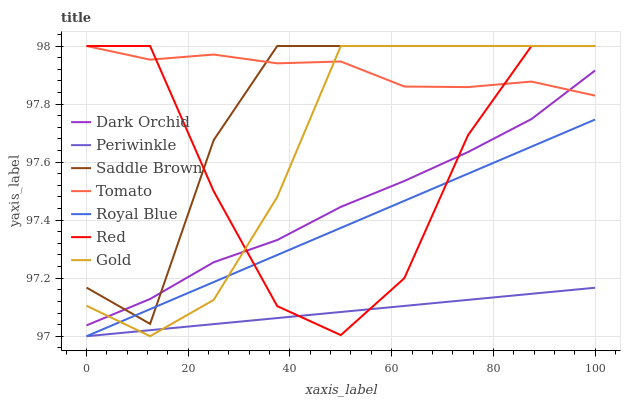Does Periwinkle have the minimum area under the curve?
Answer yes or no. Yes. Does Tomato have the maximum area under the curve?
Answer yes or no. Yes. Does Gold have the minimum area under the curve?
Answer yes or no. No. Does Gold have the maximum area under the curve?
Answer yes or no. No. Is Royal Blue the smoothest?
Answer yes or no. Yes. Is Red the roughest?
Answer yes or no. Yes. Is Gold the smoothest?
Answer yes or no. No. Is Gold the roughest?
Answer yes or no. No. Does Royal Blue have the lowest value?
Answer yes or no. Yes. Does Gold have the lowest value?
Answer yes or no. No. Does Red have the highest value?
Answer yes or no. Yes. Does Dark Orchid have the highest value?
Answer yes or no. No. Is Periwinkle less than Tomato?
Answer yes or no. Yes. Is Dark Orchid greater than Royal Blue?
Answer yes or no. Yes. Does Dark Orchid intersect Red?
Answer yes or no. Yes. Is Dark Orchid less than Red?
Answer yes or no. No. Is Dark Orchid greater than Red?
Answer yes or no. No. Does Periwinkle intersect Tomato?
Answer yes or no. No. 